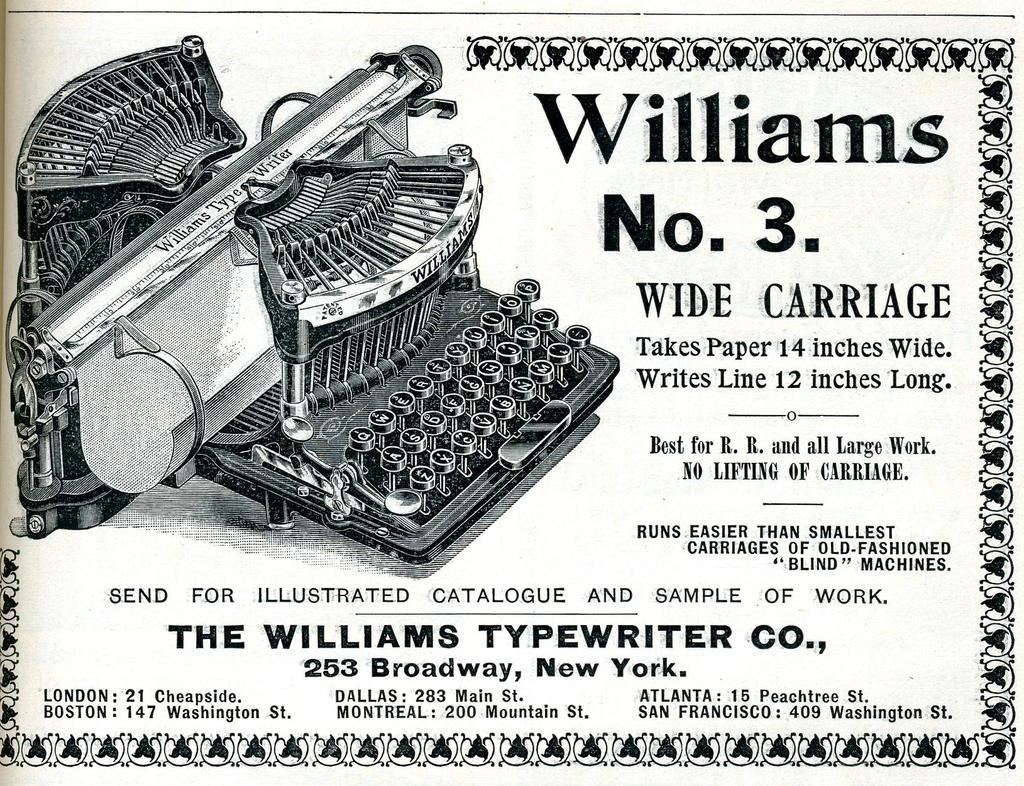<image>
Present a compact description of the photo's key features. An ad for The Williams Typewriter company shows the Williams No. 3. 